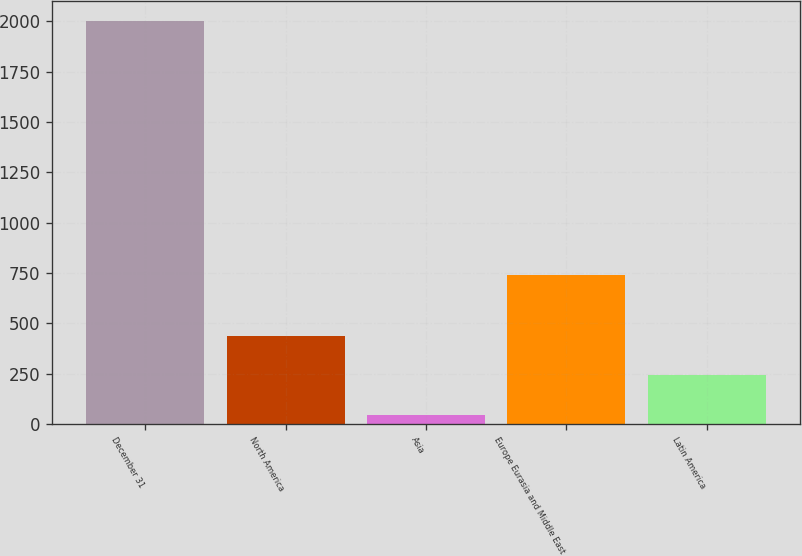<chart> <loc_0><loc_0><loc_500><loc_500><bar_chart><fcel>December 31<fcel>North America<fcel>Asia<fcel>Europe Eurasia and Middle East<fcel>Latin America<nl><fcel>2003<fcel>436.6<fcel>45<fcel>742<fcel>240.8<nl></chart> 